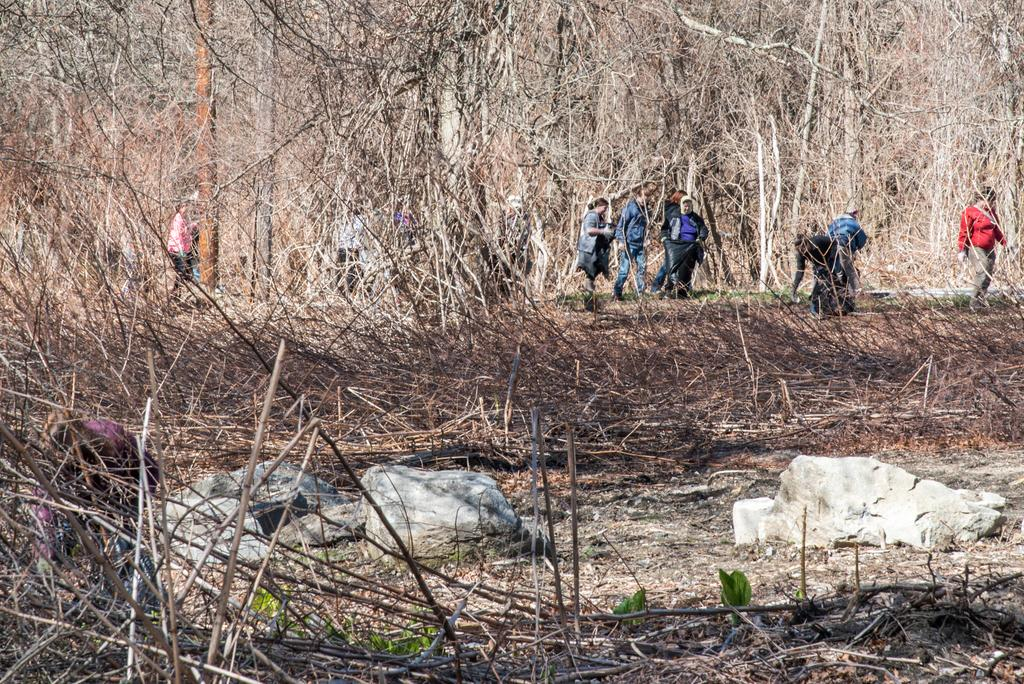What type of natural elements can be seen in the image? There are rocks and branches visible in the image. Can you describe the people in the image? There is a group of people in the image. What type of caption is written on the border of the image? There is no caption or border present in the image. How many dimes can be seen on the rocks in the image? There are no dimes visible in the image; only rocks and branches are present. 